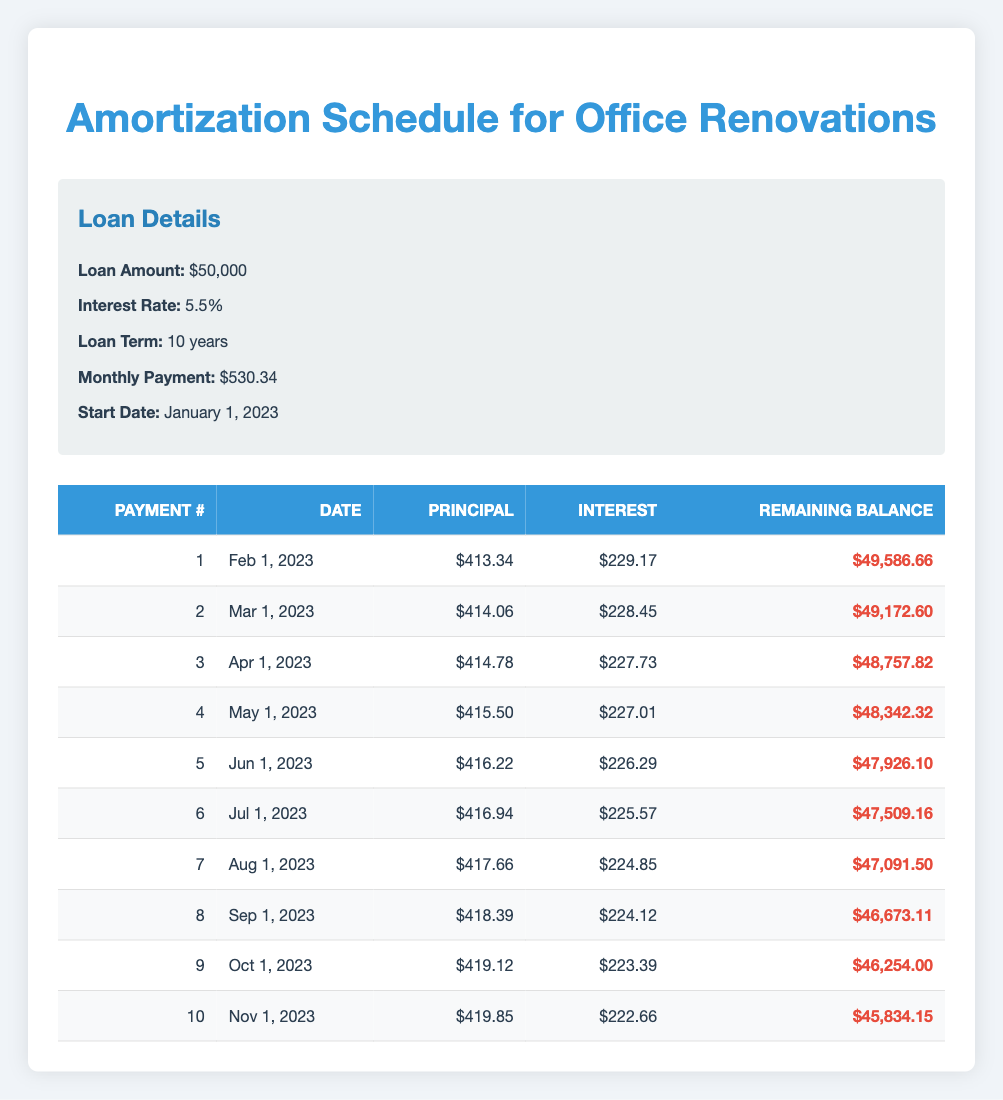What is the total interest paid in the first two payments? To find the total interest paid in the first two payments, we need to add the interest payments from both rows. For payment 1, the interest payment is 229.17, and for payment 2, it is 228.45. Adding these together gives us 229.17 + 228.45 = 457.62.
Answer: 457.62 What is the remaining balance after the third payment? Referring to the table, the remaining balance after the third payment is displayed in the third row, which is 48757.82.
Answer: 48757.82 Is the principal payment for the first payment greater than 400? Looking at the first payment row, the principal payment is 413.34, which is greater than 400. Therefore, this statement is true.
Answer: Yes What is the difference between the principal payment of the first payment and the last payment in the table? To find the difference, we subtract the principal payment of the last payment (419.85) from the first payment (413.34). The calculation is 413.34 - 419.85 = -6.51, which results in a difference of funds.
Answer: -6.51 How many payments are scheduled before the remaining balance is less than 47000? We can inspect the scheduled payments until the remaining balance is below 47000, which occurs between the 7th (47091.50) and 8th payments (46673.11). Thus, it takes 8 scheduled payments before the balance drops below 47000.
Answer: 8 What is the average monthly principal payment for the first five payments? To find the average, we need to sum the principal payments for the first five payments: 413.34 + 414.06 + 414.78 + 415.50 + 416.22 = 2083.90. Then, we divide by 5 to get the average: 2083.90 / 5 = 416.78.
Answer: 416.78 What is the interest payment on the 10th payment? The interest payment on the 10th payment can be found in the last row of the table, which indicates it is 222.66.
Answer: 222.66 Will the total of interest payments over the first ten payments exceed 2250? First, we need to calculate the total interest for the first ten payments. The interest payments from the table are: 229.17 + 228.45 + 227.73 + 227.01 + 226.29 + 225.57 + 224.85 + 224.12 + 223.39 + 222.66 = 2249.49 which is less than 2250. Therefore, the answer is no.
Answer: No What is the total principal paid after three payments? To calculate the total principal paid after three payments, we add the principal payments after each of the three payments: 413.34 (first) + 414.06 (second) + 414.78 (third) = 1242.18. Thus, the total principal paid after three payments is 1242.18.
Answer: 1242.18 